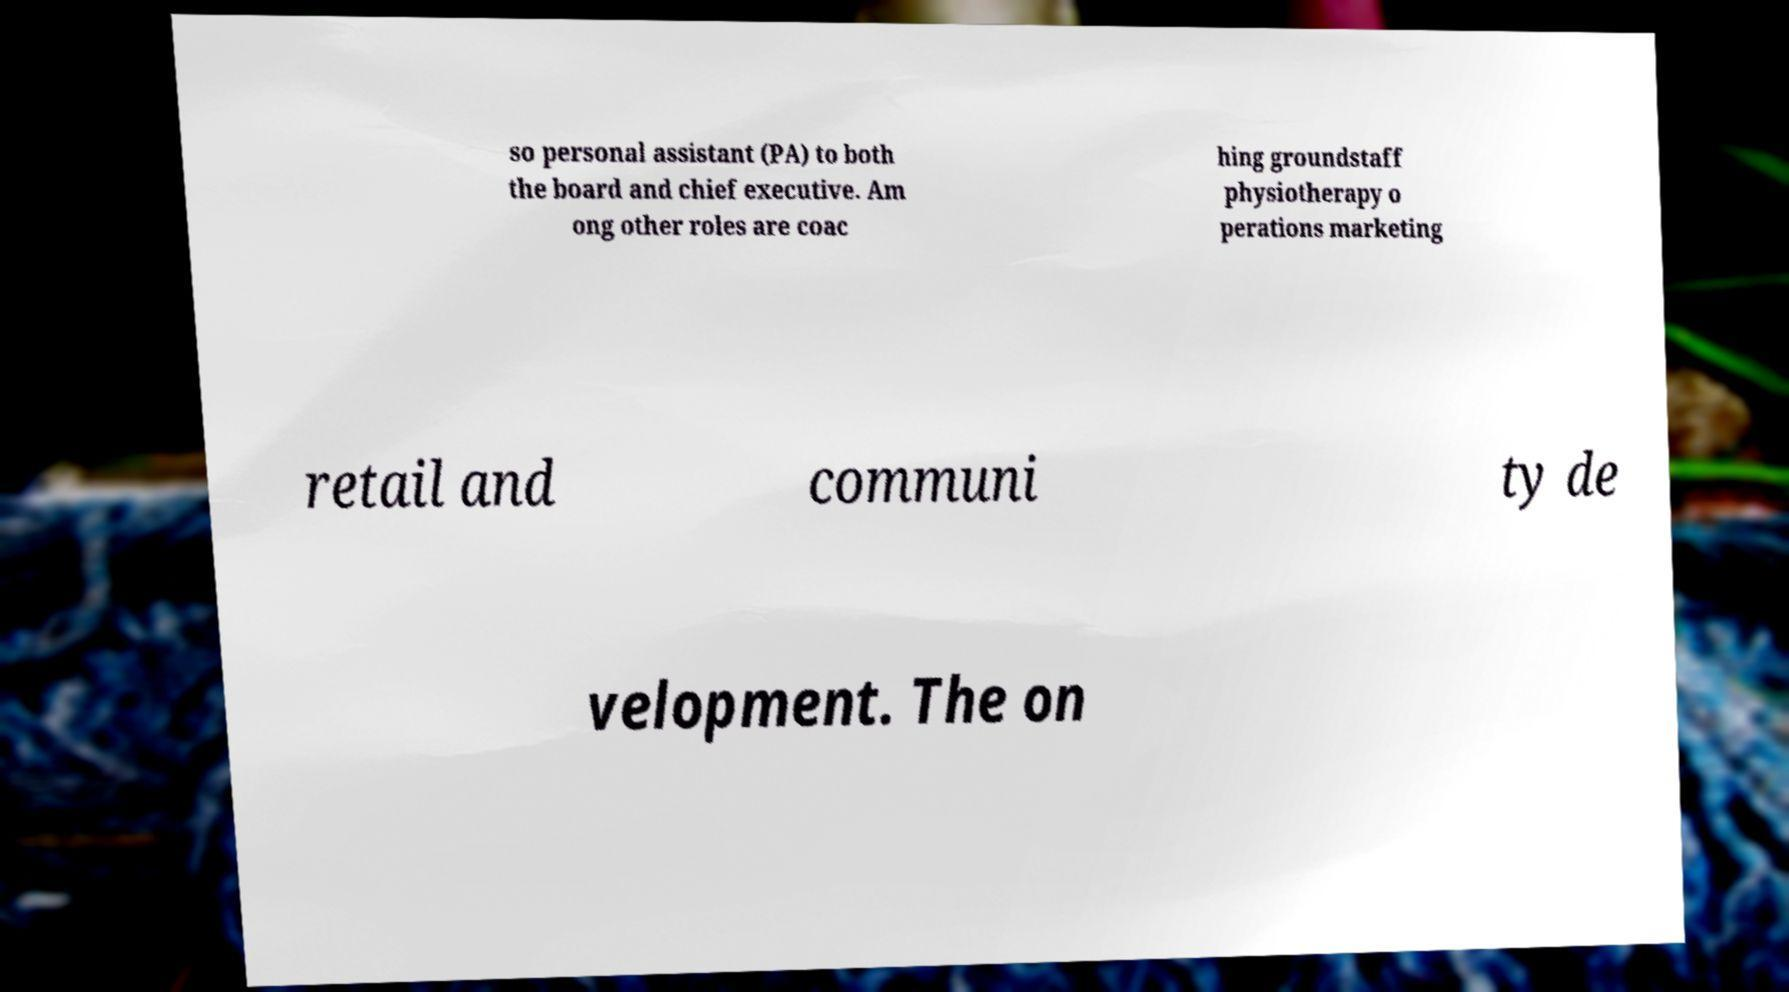There's text embedded in this image that I need extracted. Can you transcribe it verbatim? so personal assistant (PA) to both the board and chief executive. Am ong other roles are coac hing groundstaff physiotherapy o perations marketing retail and communi ty de velopment. The on 